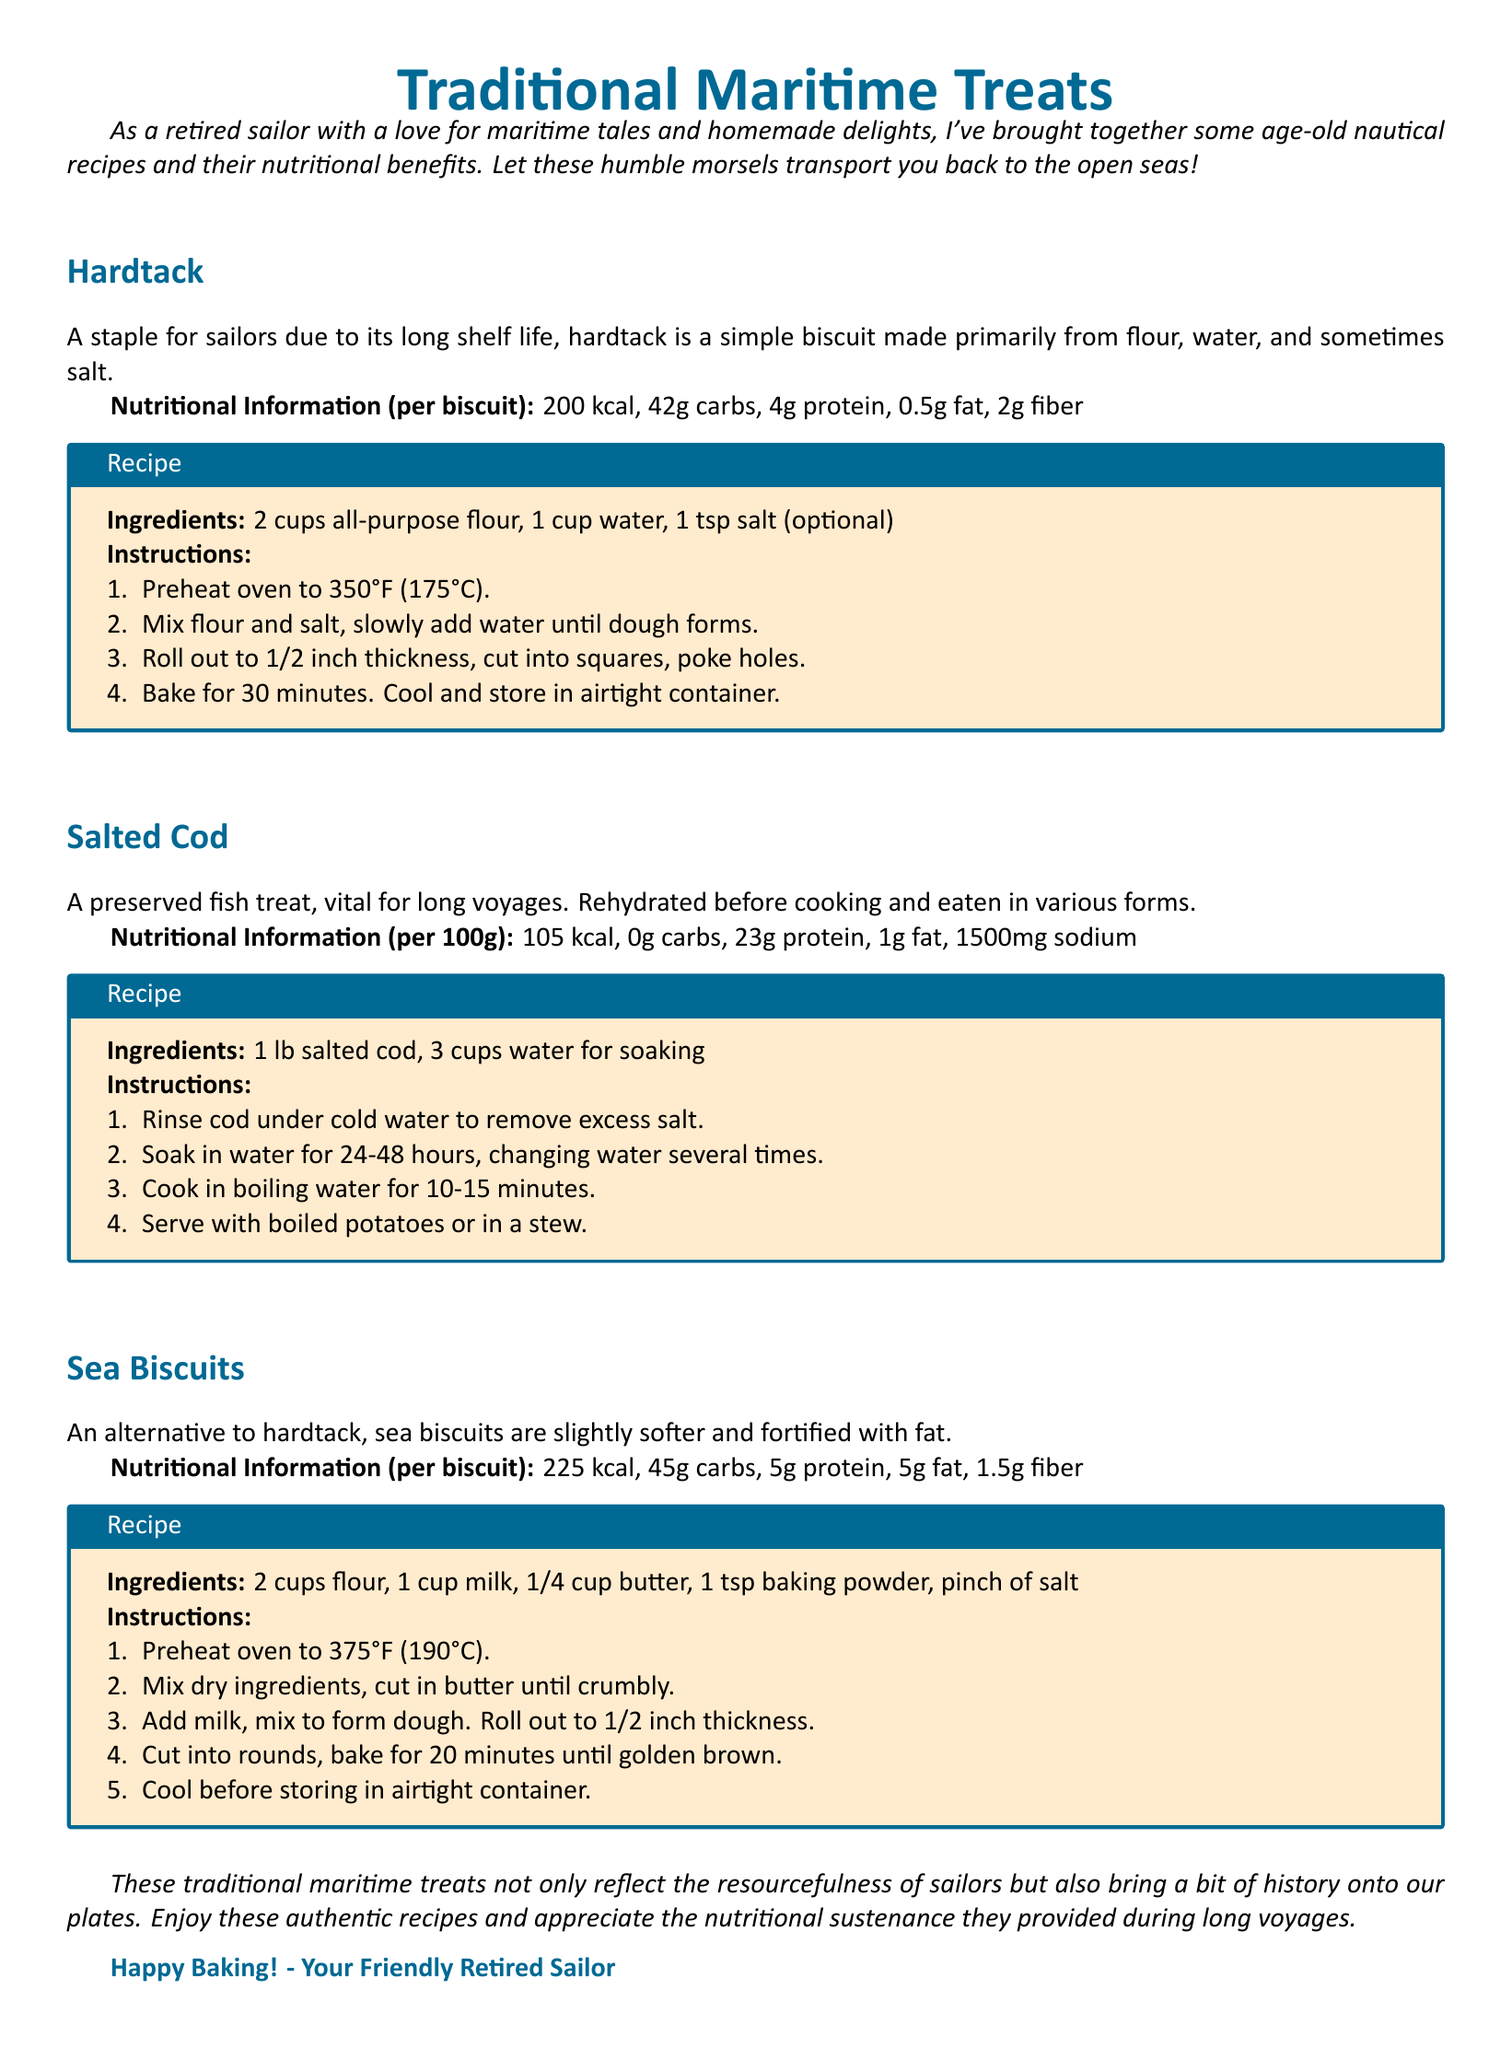What is hardtack made from? Hardtack is primarily made from flour, water, and sometimes salt, as stated in the document.
Answer: Flour, water, and salt What is the caloric content of one sea biscuit? The document specifies that one sea biscuit contains 225 kcal.
Answer: 225 kcal How many grams of protein are in salted cod per 100 grams? The nutritional information indicates that there are 23 grams of protein per 100 grams of salted cod.
Answer: 23g protein What is the baking temperature for hardtack? According to the instructions, hardtack is baked at 350°F (175°C).
Answer: 350°F (175°C) How long should salted cod be soaked? The document advises soaking salted cod for 24-48 hours before cooking.
Answer: 24-48 hours What type of document is this? This is a comprehensive guide specifically focusing on nutritional values and recipes of traditional maritime treats.
Answer: Fact sheet Which treat is an alternative to hardtack? The document states that sea biscuits serve as an alternative to hardtack.
Answer: Sea biscuits How many cups of flour are needed for sea biscuits? The recipe for sea biscuits requires 2 cups of flour, as indicated in the ingredients list.
Answer: 2 cups 